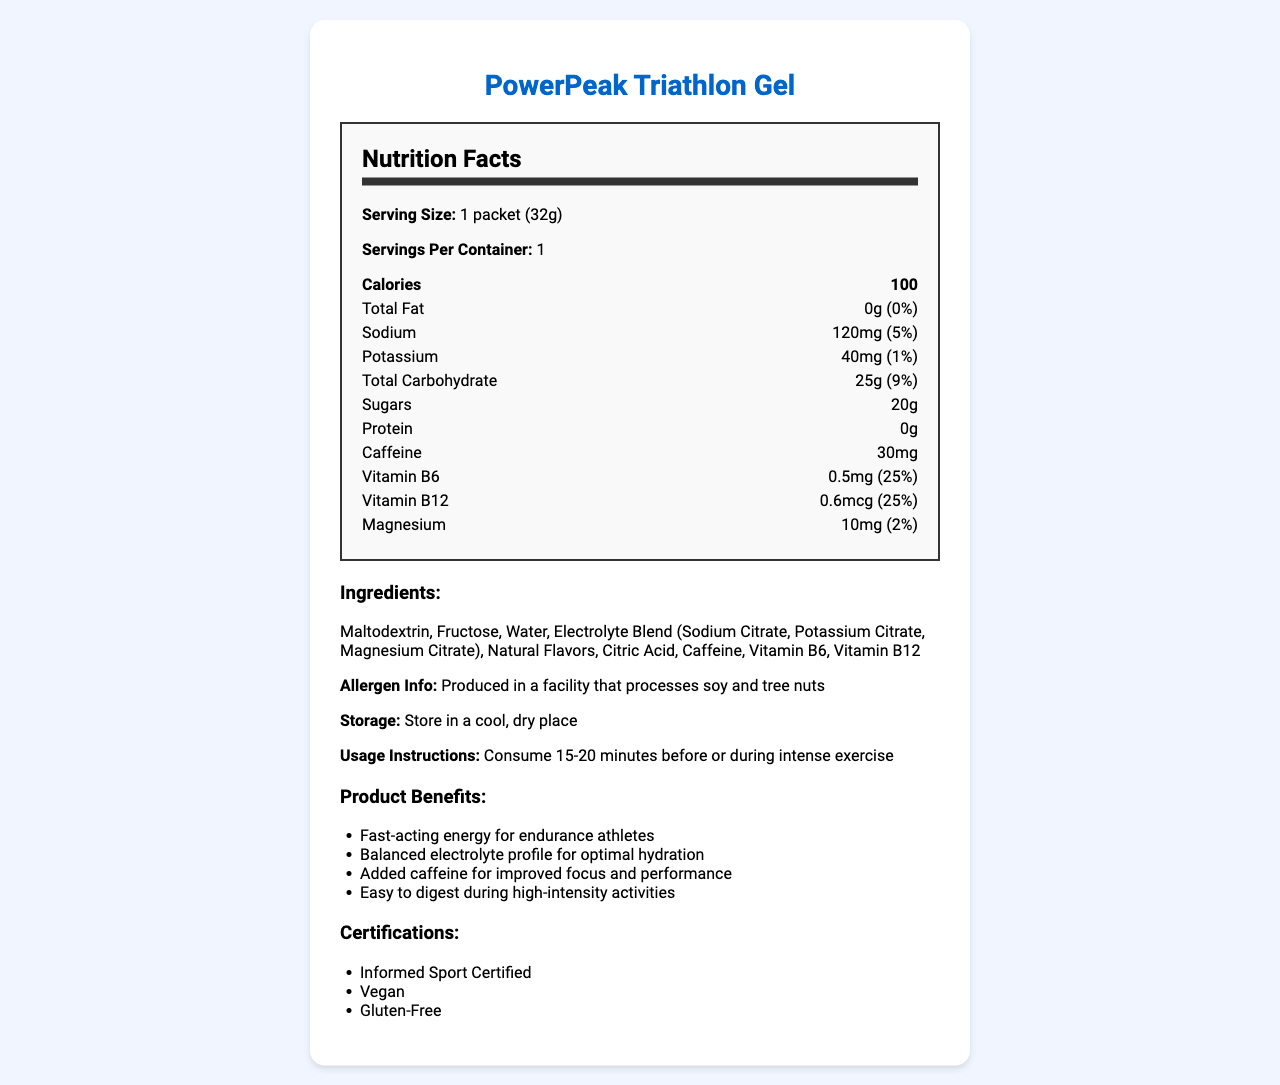what is the product name? The product name is clearly stated at the beginning of the document.
Answer: PowerPeak Triathlon Gel what is the serving size for the energy gel? The serving size is listed under the "Serving Size" section of the nutrition facts.
Answer: 1 packet (32g) how many calories are in one serving? The number of calories per serving is highlighted in the bold section of the nutrition facts.
Answer: 100 how much caffeine does the gel contain? The amount of caffeine is listed under the nutrition facts in the nutrition-item section.
Answer: 30mg what is the daily value percentage for total carbohydrate? The daily value percentage for total carbohydrate is mentioned alongside the amount, 25g (9%).
Answer: 9% how much sodium is in the gel? The amount of sodium per serving is provided in the nutrition-item section of the nutrition facts.
Answer: 120mg how much Vitamin B6 is in one packet of the gel? The amount of Vitamin B6 is clearly indicated in the nutrition facts under its respective heading.
Answer: 0.5mg what are the storage instructions for the gel? The storage instructions are specified towards the bottom of the document.
Answer: Store in a cool, dry place what allergens might be present in the gel? A. Dairy B. Soy C. Peanuts D. Gluten The allergen information indicates that the product is produced in a facility that processes soy and tree nuts.
Answer: B which of the following is a benefit of the gel? A. Slow-release energy B. Contains fiber C. Fast-acting energy for endurance athletes D. Low-caffeine content The document lists "Fast-acting energy for endurance athletes" as one of the product benefits.
Answer: C is the PowerPeak Triathlon Gel gluten-free? The certifications clearly state that the product is gluten-free.
Answer: Yes what are some of the key ingredients in the gel? The ingredients are listed in the ingredients section and include Maltodextrin, Fructose, Water, Electrolyte Blend, and Caffeine.
Answer: Maltodextrin, Fructose, Water, Electrolyte Blend, Caffeine how should the gel be used during a triathlon? The usage instructions specify the optimal time to consume the gel for best performance.
Answer: Consume 15-20 minutes before or during intense exercise summarize the main nutritional benefits of PowerPeak Triathlon Gel. The document gives a comprehensive view of the product's nutrition facts, benefits, usage instructions, ingredients, allergen information, storage instructions, and certifications, which highlight its suitability for endurance athletes.
Answer: The PowerPeak Triathlon Gel provides fast-acting energy, balanced electrolytes, added caffeine for focus, and is easy to digest. It offers 100 calories, 25g of carbohydrates, and crucial vitamins and minerals for endurance athletes. how many grams of protein are in the gel? The amount of protein is clearly listed as 0g in the nutrition facts section.
Answer: 0g can the exact manufacturing location be determined from the document? The document provides allergen information but does not specify the exact manufacturing location.
Answer: Not enough information is Vitamin C listed as one of the ingredients in the gel? The list of ingredients does not include Vitamin C; it's not mentioned in any part of the document.
Answer: No 